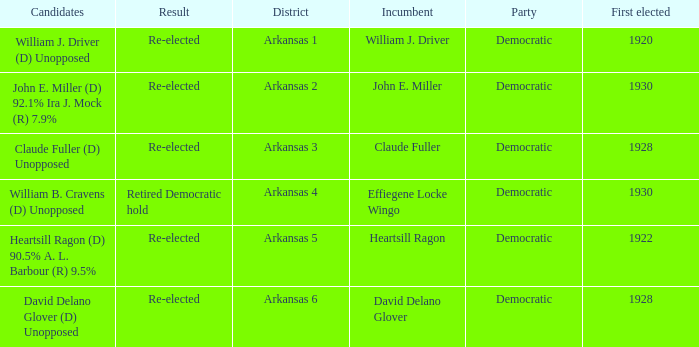Who ran in the election where Claude Fuller was the incumbent?  Claude Fuller (D) Unopposed. 